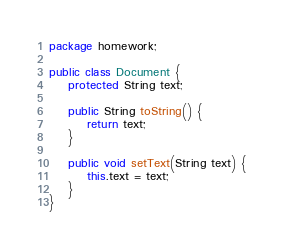<code> <loc_0><loc_0><loc_500><loc_500><_Java_>package homework;

public class Document {
	protected String text;

	public String toString() {
		return text;
	}

	public void setText(String text) {
		this.text = text;
	}
}
</code> 